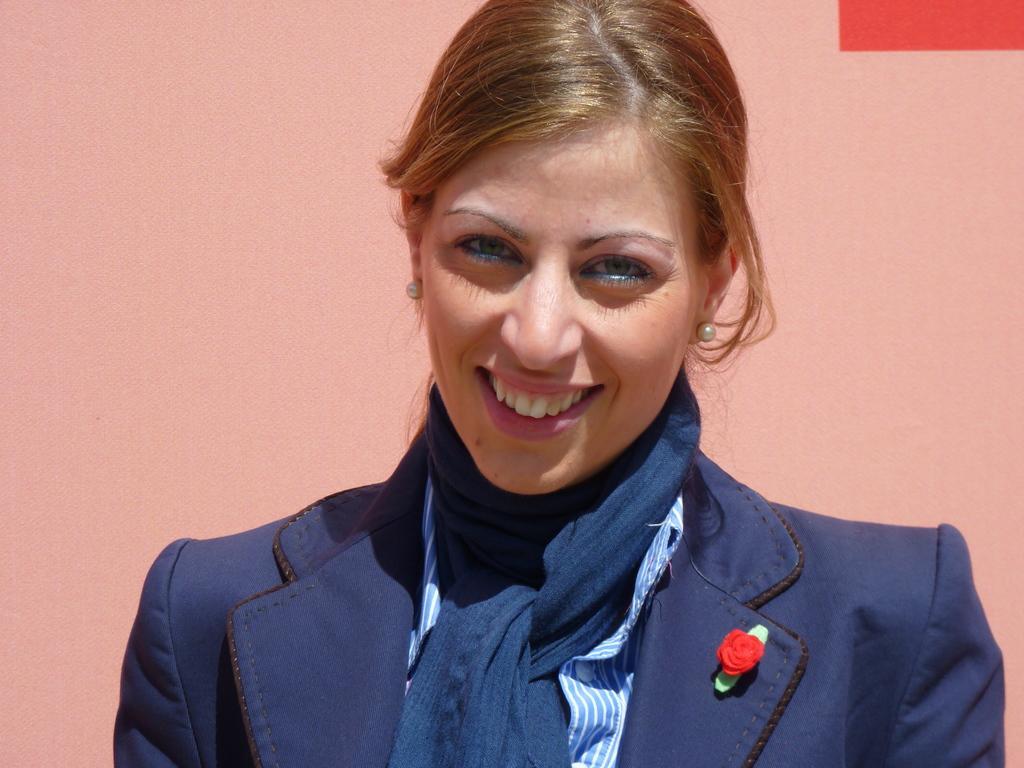Please provide a concise description of this image. This picture shows a woman standing and we see smile on her face. She wore a blue coat and a blue scarf and we see light pink color wall on the back. 